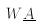<formula> <loc_0><loc_0><loc_500><loc_500>W \underline { A }</formula> 